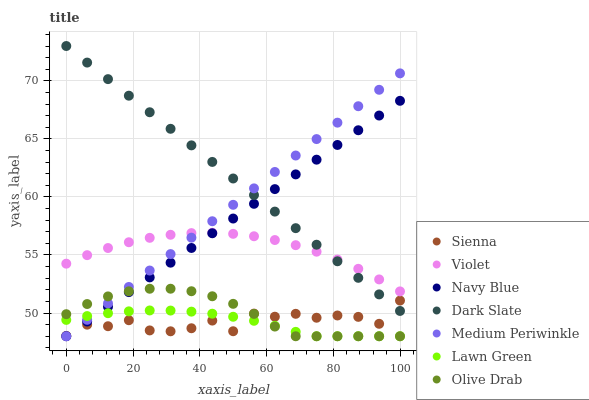Does Lawn Green have the minimum area under the curve?
Answer yes or no. Yes. Does Dark Slate have the maximum area under the curve?
Answer yes or no. Yes. Does Navy Blue have the minimum area under the curve?
Answer yes or no. No. Does Navy Blue have the maximum area under the curve?
Answer yes or no. No. Is Navy Blue the smoothest?
Answer yes or no. Yes. Is Sienna the roughest?
Answer yes or no. Yes. Is Medium Periwinkle the smoothest?
Answer yes or no. No. Is Medium Periwinkle the roughest?
Answer yes or no. No. Does Lawn Green have the lowest value?
Answer yes or no. Yes. Does Sienna have the lowest value?
Answer yes or no. No. Does Dark Slate have the highest value?
Answer yes or no. Yes. Does Navy Blue have the highest value?
Answer yes or no. No. Is Lawn Green less than Dark Slate?
Answer yes or no. Yes. Is Violet greater than Olive Drab?
Answer yes or no. Yes. Does Sienna intersect Lawn Green?
Answer yes or no. Yes. Is Sienna less than Lawn Green?
Answer yes or no. No. Is Sienna greater than Lawn Green?
Answer yes or no. No. Does Lawn Green intersect Dark Slate?
Answer yes or no. No. 